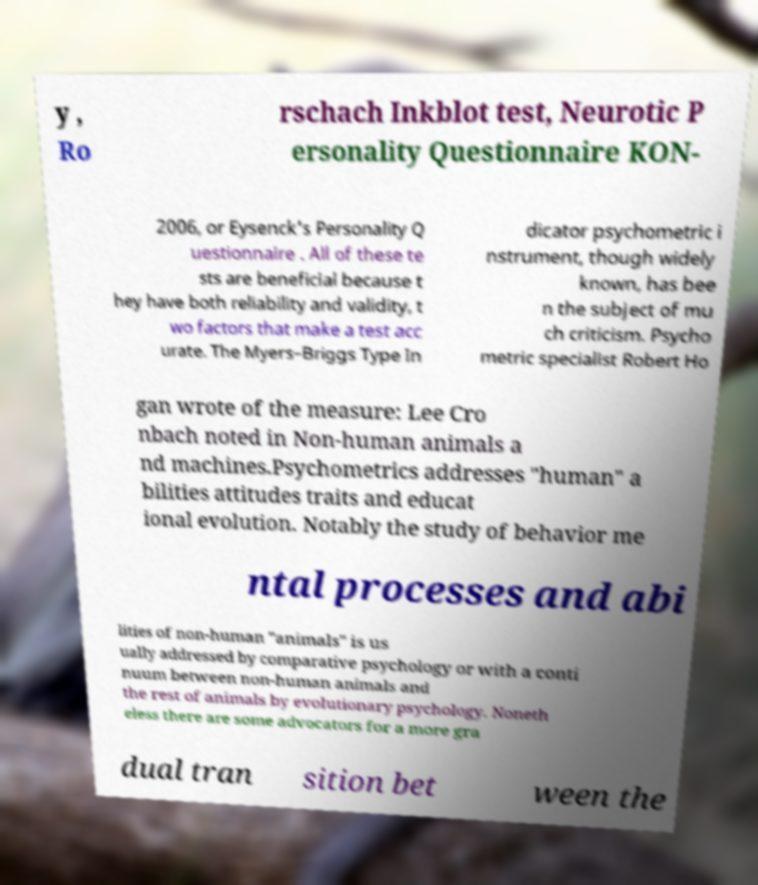Can you read and provide the text displayed in the image?This photo seems to have some interesting text. Can you extract and type it out for me? y , Ro rschach Inkblot test, Neurotic P ersonality Questionnaire KON- 2006, or Eysenck's Personality Q uestionnaire . All of these te sts are beneficial because t hey have both reliability and validity, t wo factors that make a test acc urate. The Myers–Briggs Type In dicator psychometric i nstrument, though widely known, has bee n the subject of mu ch criticism. Psycho metric specialist Robert Ho gan wrote of the measure: Lee Cro nbach noted in Non-human animals a nd machines.Psychometrics addresses "human" a bilities attitudes traits and educat ional evolution. Notably the study of behavior me ntal processes and abi lities of non-human "animals" is us ually addressed by comparative psychology or with a conti nuum between non-human animals and the rest of animals by evolutionary psychology. Noneth eless there are some advocators for a more gra dual tran sition bet ween the 